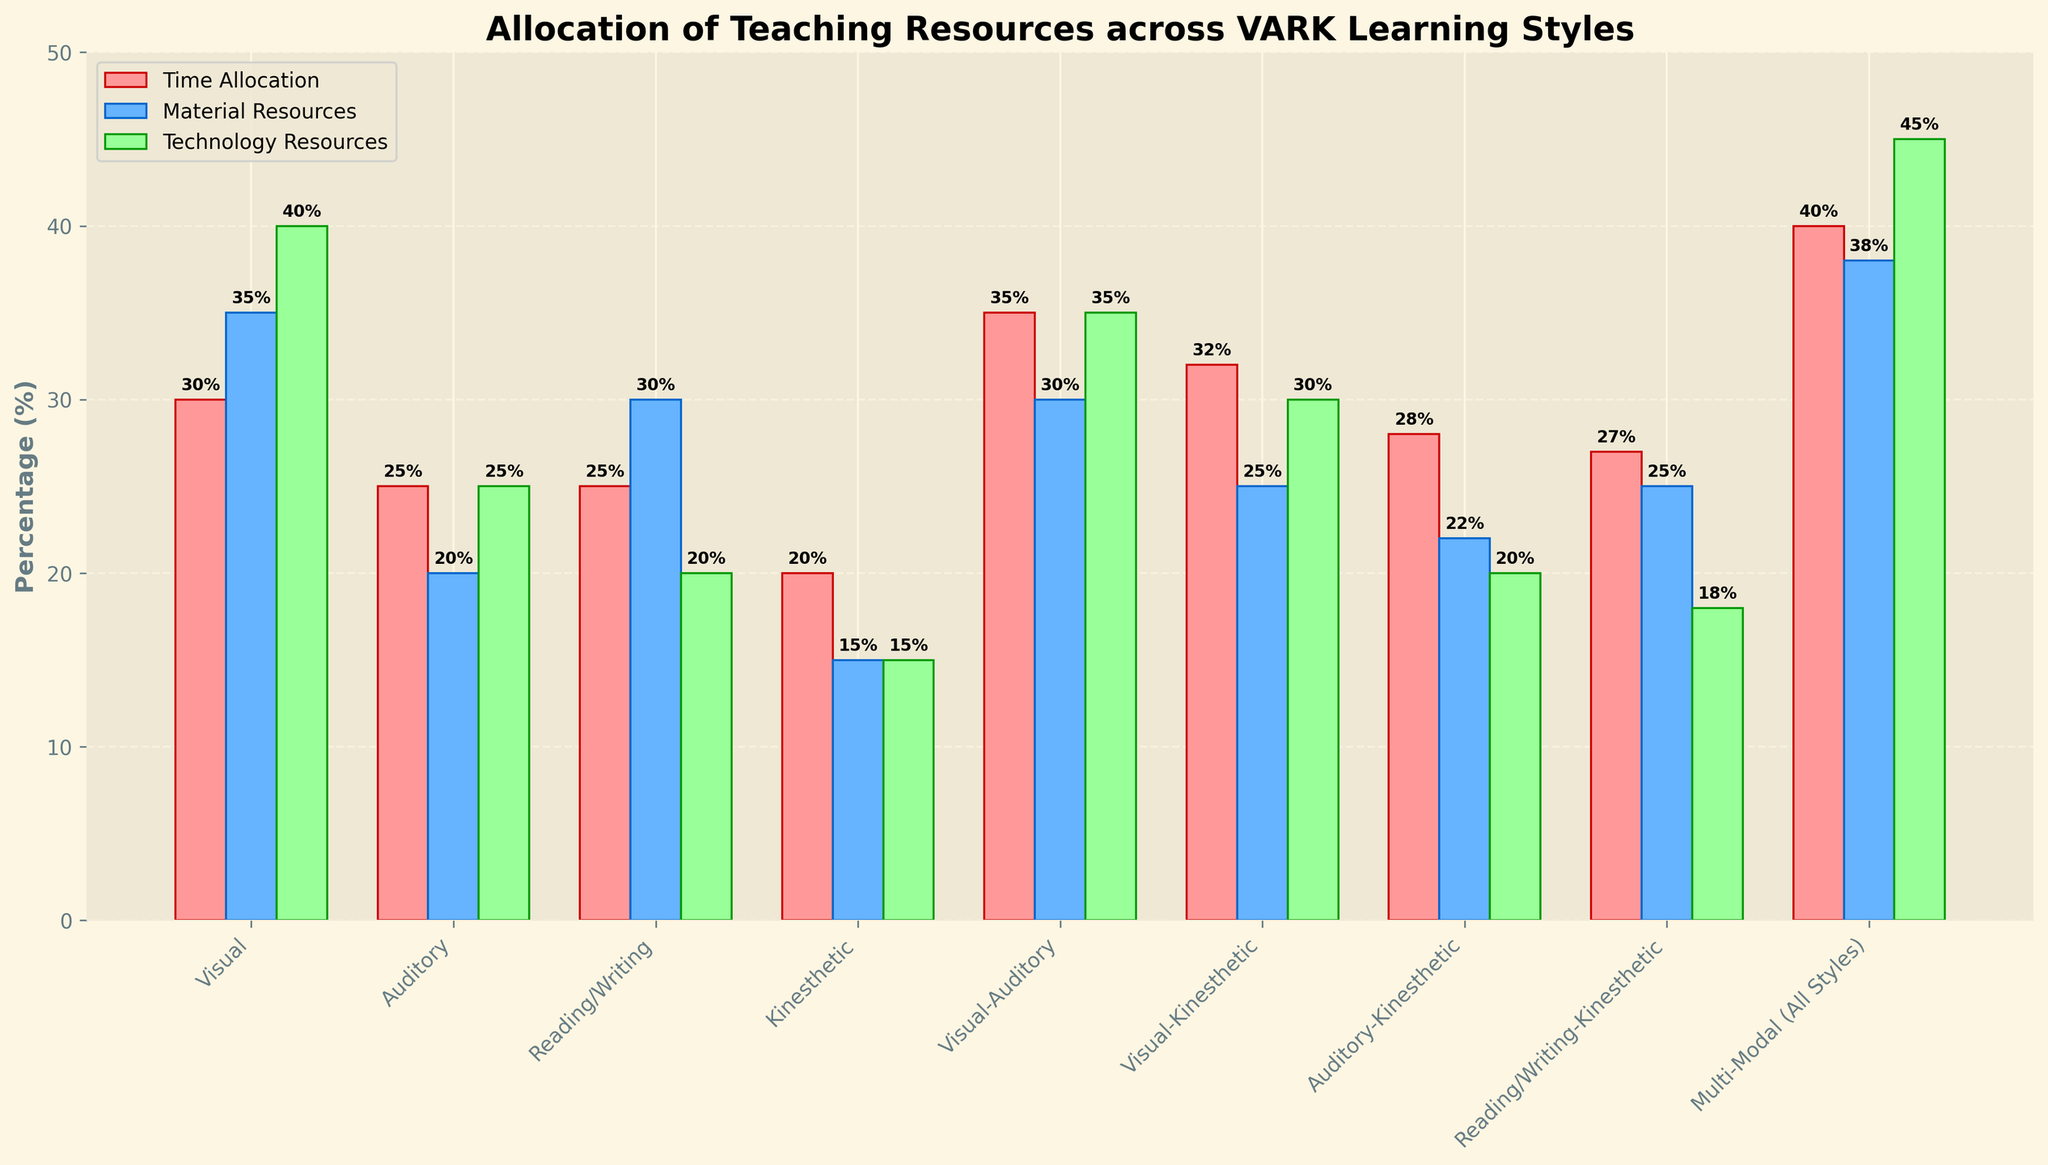What is the total percentage of resources allocated to the Visual-Auditory and Kinesthetic learning styles in terms of technology? Add the technology resources percentage for both learning styles: Visual-Auditory (35%) + Kinesthetic (15%). So, 35 + 15 = 50.
Answer: 50% Which learning style has the highest percentage allocation of material resources? The Visual learning style has the highest material resources allocation at 35%.
Answer: Visual Are material resources more allocated to the Visual or Auditory learning styles? The Visual learning style has 35% material resources, while the Auditory learning style has 20%. 35% is greater than 20%.
Answer: Visual What is the difference in time allocation between the Kinesthetic and Visual learning styles? The time allocation for Kinesthetic is 20% and for Visual is 30%. The difference is 30 - 20 = 10.
Answer: 10% Which learning attitude receives the least allocation of technology resources? The Reading/Writing-Kinesthetic learning style receives the least at 18%.
Answer: Reading/Writing-Kinesthetic What are the combined percentages of time and material resources allocated to the Multi-Modal learning style? The time allocation is 40% and material resources allocation is 38%. So, 40 + 38 = 78.
Answer: 78% Which learning style has equal allocations of time and technology resources? Both time and technology resources for Visual-Auditory learning style are 35%.
Answer: Visual-Auditory Which learning style with a combination of two styles, excluding Multi-Modal, has the most balanced allocation of all resources? Visual-Auditory has 35% (time), 30% (material), and 35% (technology), which is the most balanced.
Answer: Visual-Auditory For which learning style is the height of the material resources bar shorter than the technology resources bar, but taller than the time allocation bar? This is true for the Visual-Kinesthetic learning style: Material (25%) is shorter than Technology (30%), but taller than Time (32%).
Answer: Visual-Kinesthetic What is the average percentage of material resources allocated to the Visual and Auditory learning styles? Add the material resources percentages for both: Visual (35%) + Auditory (20%) = 55%, and divide by 2. So, 55/2 = 27.5.
Answer: 27.5% 